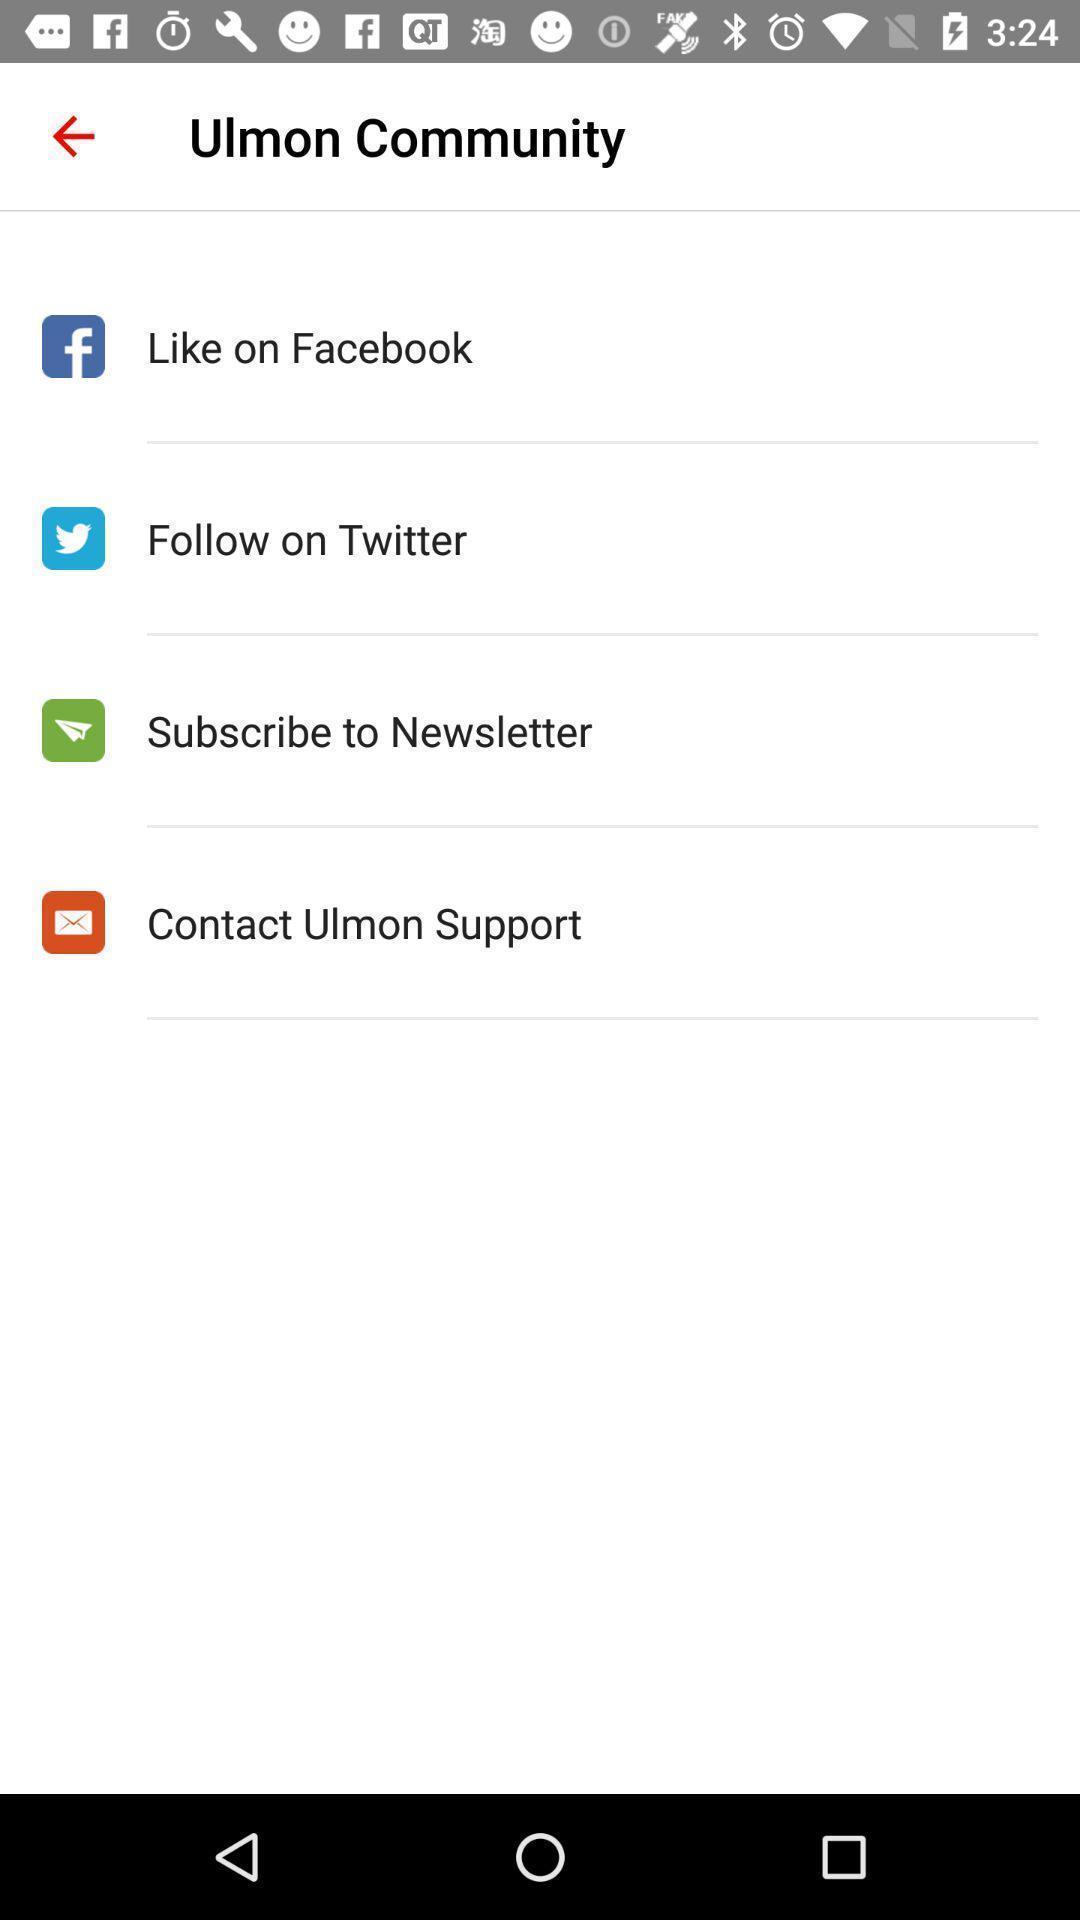Tell me about the visual elements in this screen capture. Page showing list of community options on an app. 